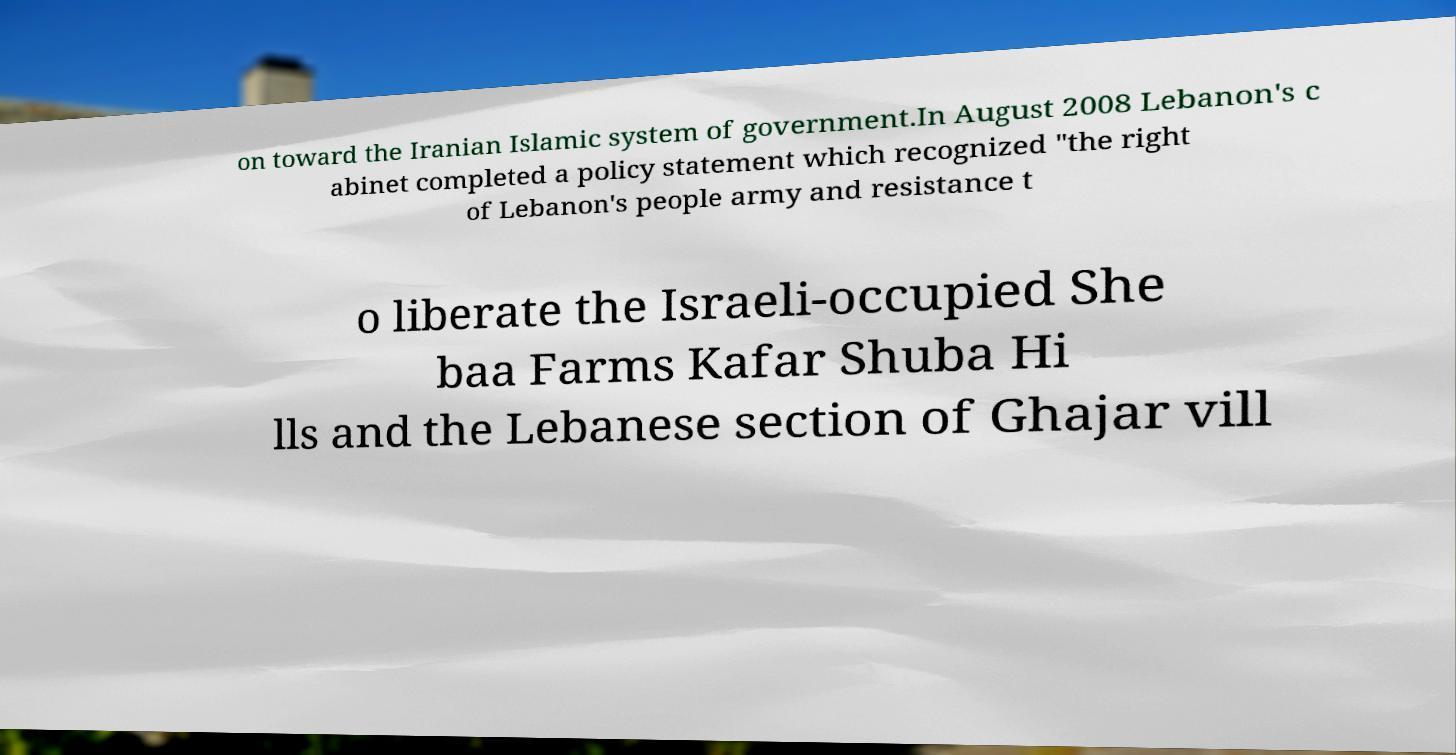For documentation purposes, I need the text within this image transcribed. Could you provide that? on toward the Iranian Islamic system of government.In August 2008 Lebanon's c abinet completed a policy statement which recognized "the right of Lebanon's people army and resistance t o liberate the Israeli-occupied She baa Farms Kafar Shuba Hi lls and the Lebanese section of Ghajar vill 